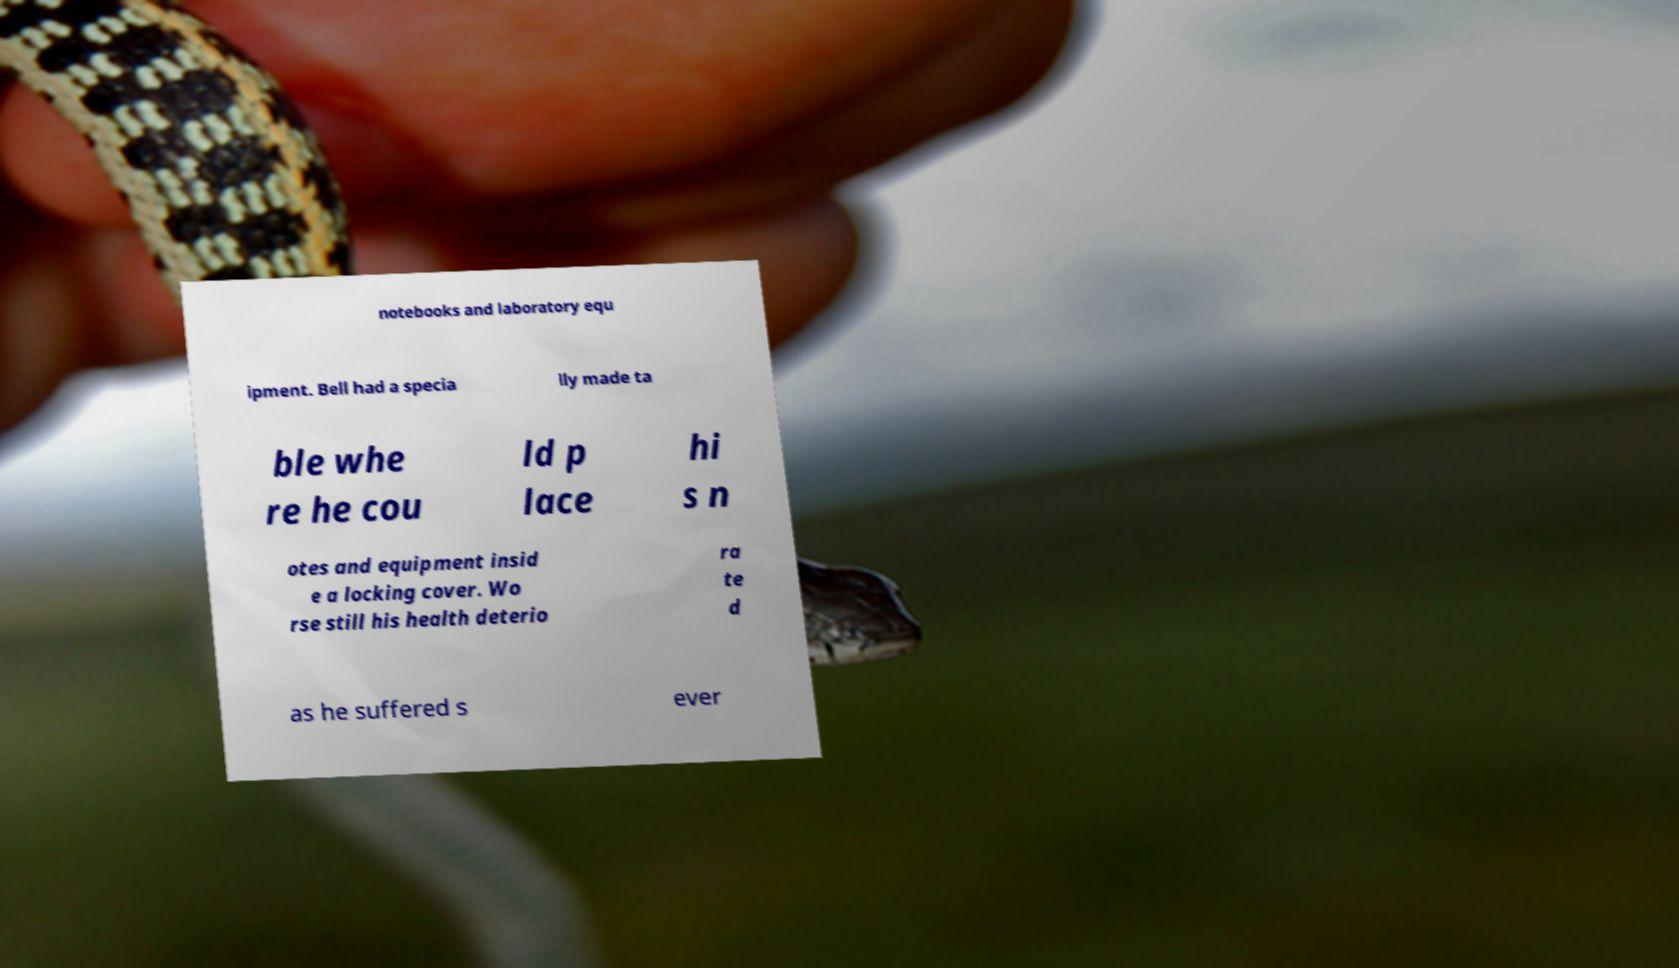There's text embedded in this image that I need extracted. Can you transcribe it verbatim? notebooks and laboratory equ ipment. Bell had a specia lly made ta ble whe re he cou ld p lace hi s n otes and equipment insid e a locking cover. Wo rse still his health deterio ra te d as he suffered s ever 